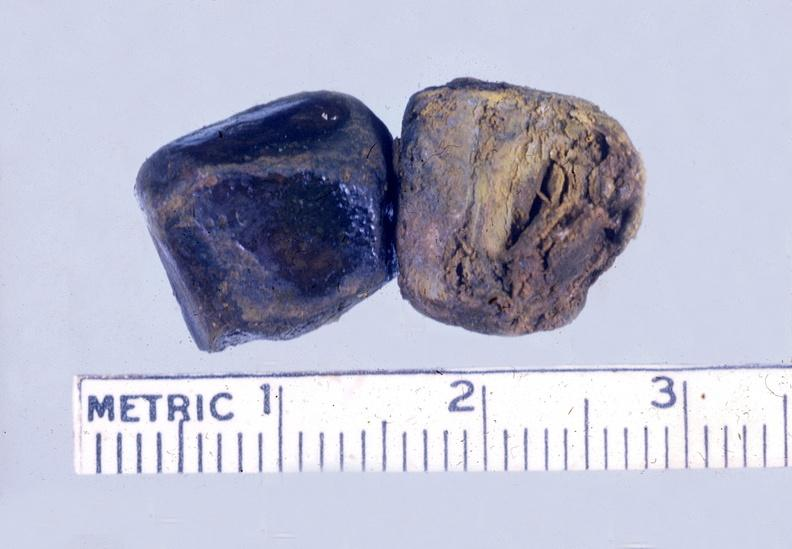what does this image show?
Answer the question using a single word or phrase. Gall bladder 